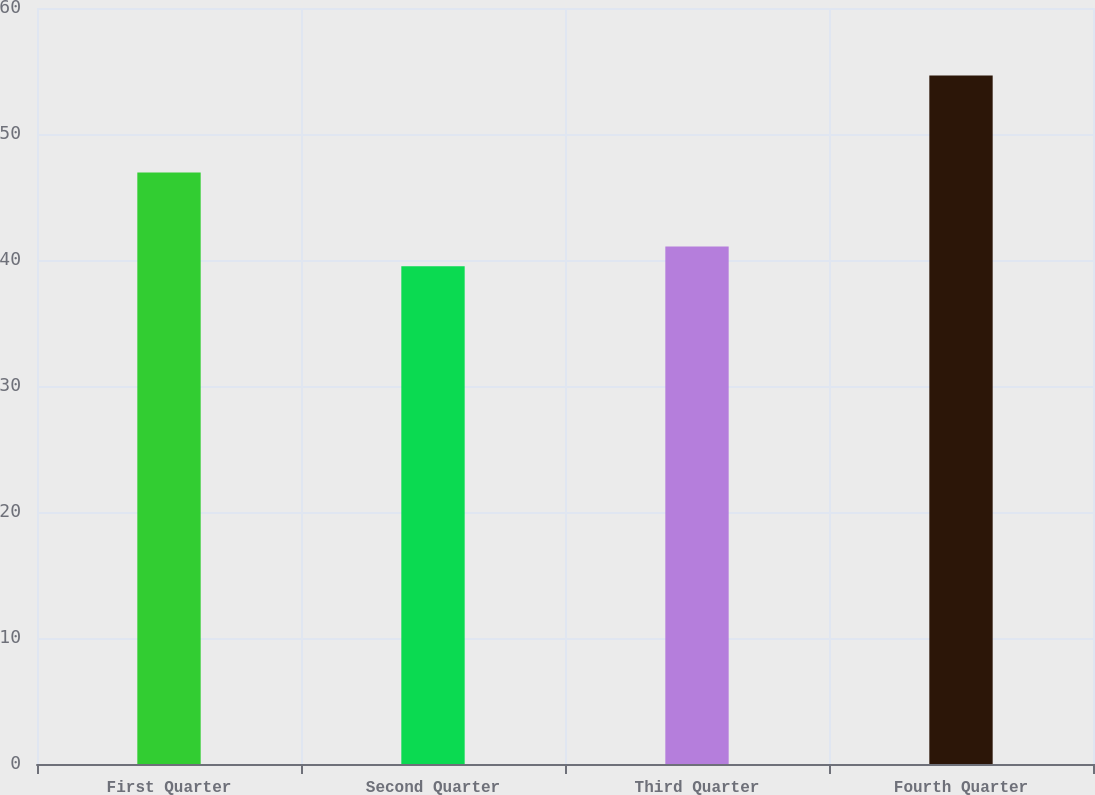<chart> <loc_0><loc_0><loc_500><loc_500><bar_chart><fcel>First Quarter<fcel>Second Quarter<fcel>Third Quarter<fcel>Fourth Quarter<nl><fcel>46.94<fcel>39.5<fcel>41.07<fcel>54.64<nl></chart> 